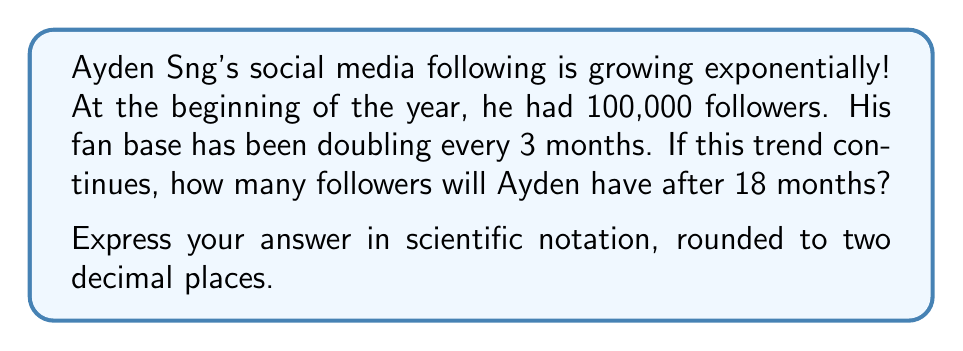Provide a solution to this math problem. Let's approach this step-by-step:

1) First, we need to identify the components of our exponential function:
   - Initial value (a): 100,000 followers
   - Growth rate (r): doubles (×2) every 3 months
   - Time (t): 18 months

2) Our exponential function will be in the form:
   $$ f(t) = a \cdot (1+r)^{\frac{t}{p}} $$
   Where p is the period over which the growth rate occurs (3 months in this case).

3) We can simplify our growth rate:
   Doubling means multiplying by 2, so r = 1 (as 1+1 = 2)

4) Now, let's plug in our values:
   $$ f(18) = 100,000 \cdot (1+1)^{\frac{18}{3}} $$

5) Simplify:
   $$ f(18) = 100,000 \cdot 2^6 $$

6) Calculate $2^6$:
   $$ f(18) = 100,000 \cdot 64 $$

7) Multiply:
   $$ f(18) = 6,400,000 $$

8) Convert to scientific notation:
   $$ f(18) = 6.4 \times 10^6 $$

Therefore, after 18 months, Ayden Sng will have approximately 6.4 million followers.
Answer: $6.40 \times 10^6$ followers 